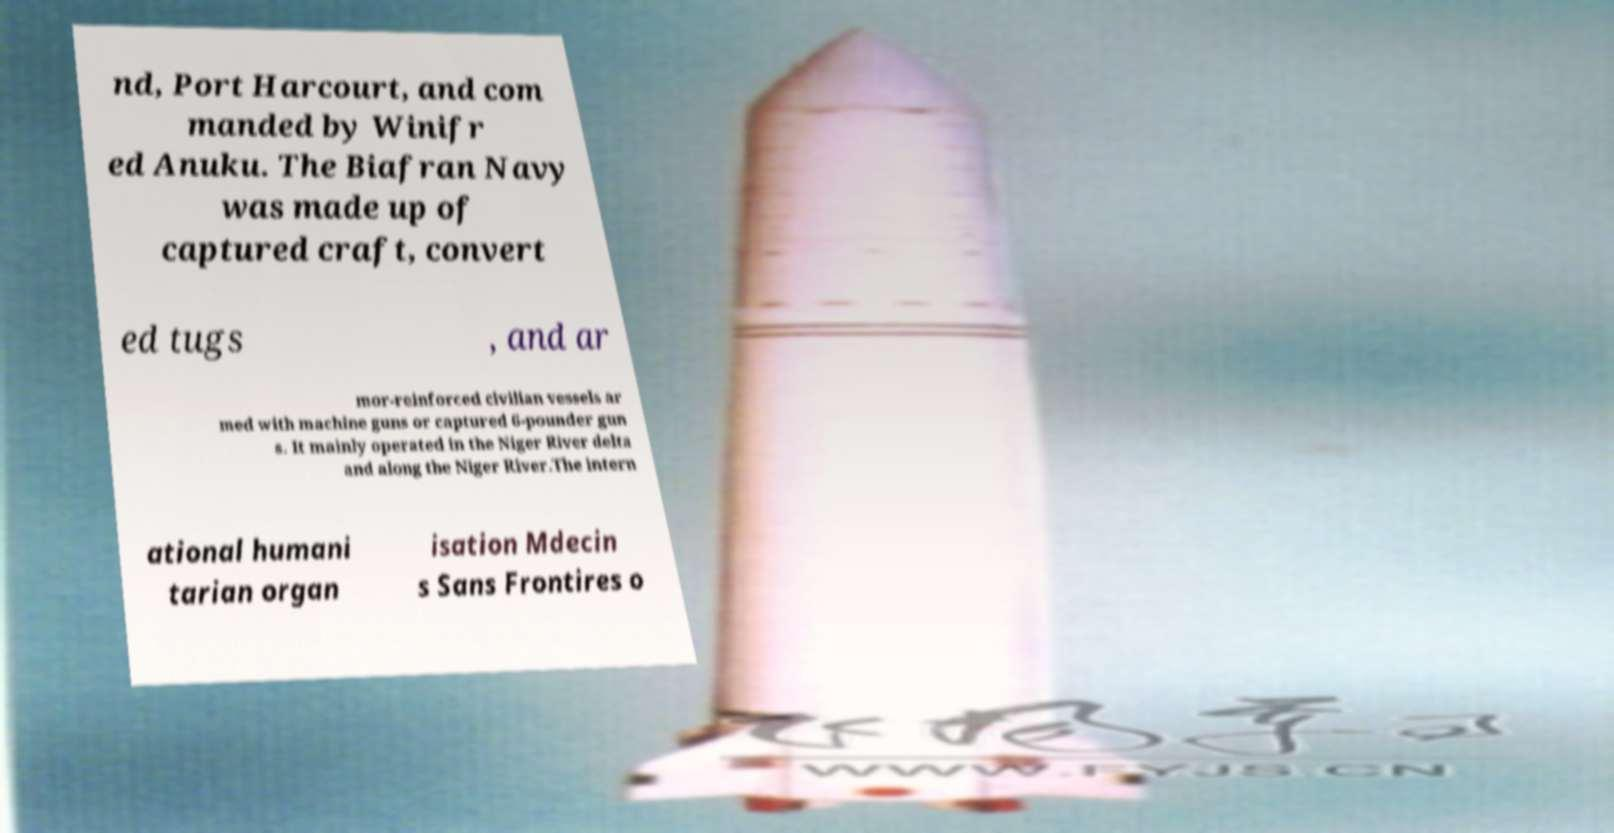There's text embedded in this image that I need extracted. Can you transcribe it verbatim? nd, Port Harcourt, and com manded by Winifr ed Anuku. The Biafran Navy was made up of captured craft, convert ed tugs , and ar mor-reinforced civilian vessels ar med with machine guns or captured 6-pounder gun s. It mainly operated in the Niger River delta and along the Niger River.The intern ational humani tarian organ isation Mdecin s Sans Frontires o 